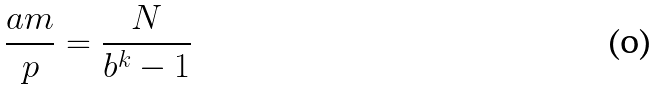Convert formula to latex. <formula><loc_0><loc_0><loc_500><loc_500>\frac { a m } { p } = \frac { N } { b ^ { k } - 1 }</formula> 